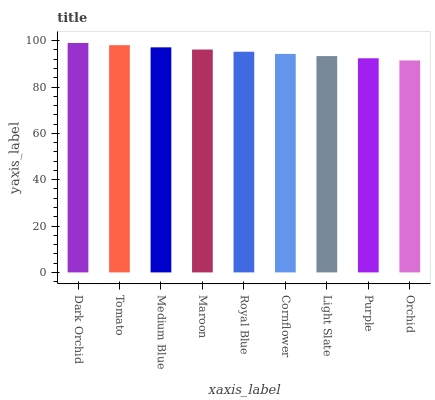Is Tomato the minimum?
Answer yes or no. No. Is Tomato the maximum?
Answer yes or no. No. Is Dark Orchid greater than Tomato?
Answer yes or no. Yes. Is Tomato less than Dark Orchid?
Answer yes or no. Yes. Is Tomato greater than Dark Orchid?
Answer yes or no. No. Is Dark Orchid less than Tomato?
Answer yes or no. No. Is Royal Blue the high median?
Answer yes or no. Yes. Is Royal Blue the low median?
Answer yes or no. Yes. Is Dark Orchid the high median?
Answer yes or no. No. Is Tomato the low median?
Answer yes or no. No. 